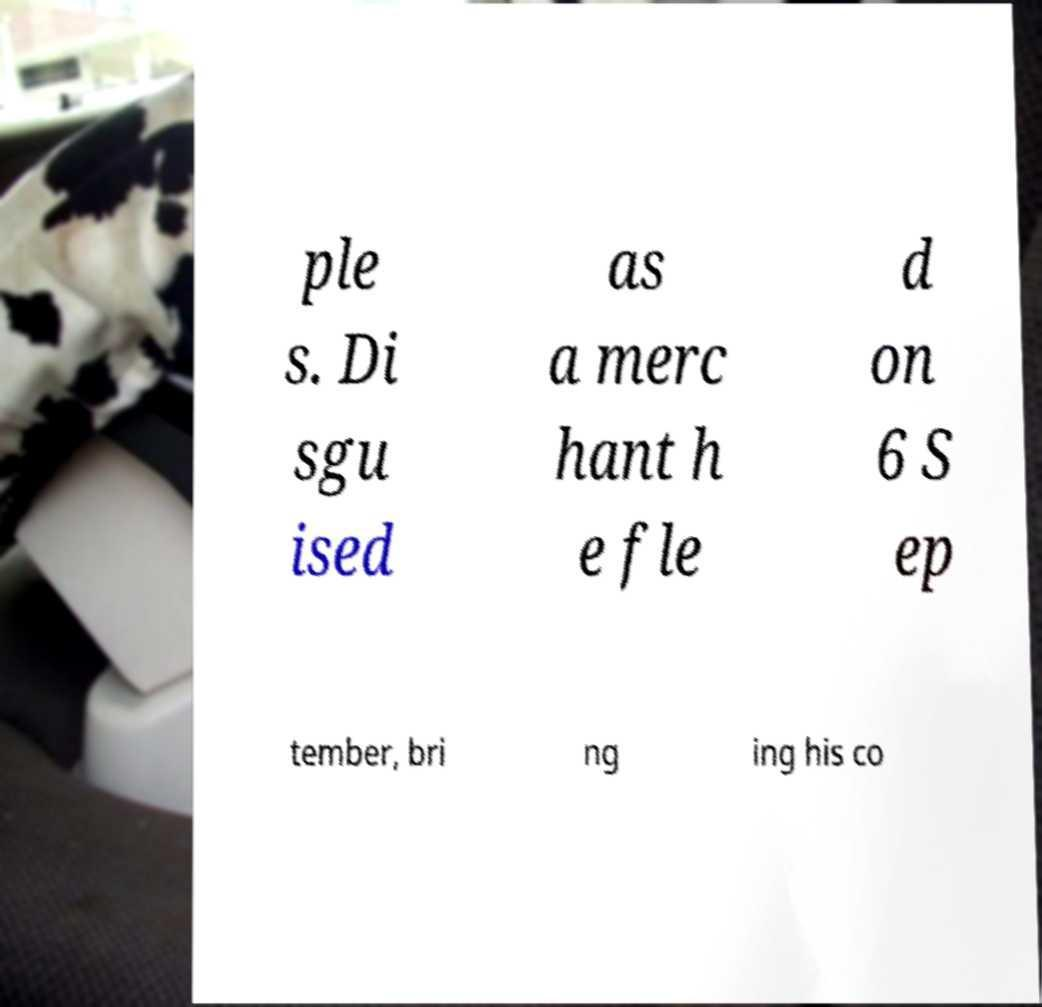Please identify and transcribe the text found in this image. ple s. Di sgu ised as a merc hant h e fle d on 6 S ep tember, bri ng ing his co 